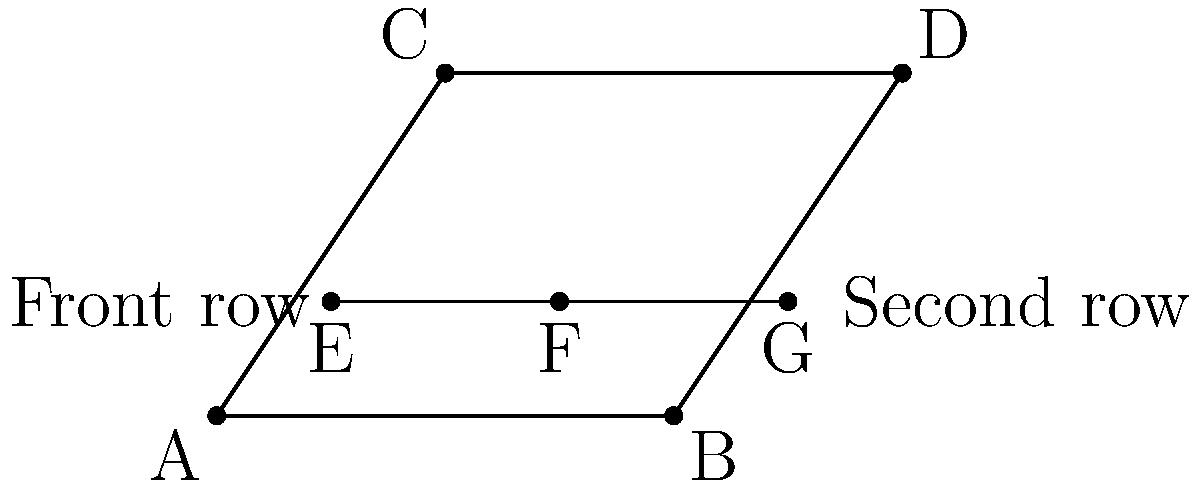In our Kelso rugby team scrum formation, we have two rows of players as shown in the diagram. The front row (triangle ABC) and the second row (triangle EFG) are formed. If AB = 4 units, EF = 2 units, and the ratio of the areas of triangles ABC and EFG is 9:1, prove that these triangles are congruent by similarity. Let's approach this step-by-step:

1) First, we need to understand what it means for triangles to be congruent by similarity. This occurs when one triangle is an enlarged or reduced version of the other, with all angles remaining the same.

2) We're given that the ratio of areas is 9:1. Let's use this information:
   Area of ABC : Area of EFG = 9 : 1

3) We know that for similar triangles, the ratio of their areas is equal to the square of the ratio of their corresponding sides. Let's call this ratio k. So:
   $k^2 = 9:1 = 9$
   $k = 3$

4) This means that each side of triangle ABC is 3 times the corresponding side of triangle EFG.

5) We're given that AB = 4 units and EF = 2 units. Let's check if this fits our ratio:
   $\frac{AB}{EF} = \frac{4}{2} = 2$

6) However, our ratio k should be 3, not 2. This means that EF is not a side corresponding to AB.

7) The corresponding side to AB in triangle EFG must be the base of the triangle, which is not EF, but the entire second row line segment in our scrum formation.

8) This base of triangle EFG must be $\frac{4}{3} = 1.33$ units long for the triangles to be similar with a scale factor of 3.

9) Given that EF = 2 units, the total length of the second row (the base of triangle EFG) must indeed be 2 + 1.33 = 3.33 units, which is $\frac{4}{3}$ of AB.

10) This confirms that the triangles are indeed similar with a scale factor of 3, which matches the given area ratio of 9:1.

Therefore, the front row triangle ABC and the triangle formed by the second row players are congruent by similarity.
Answer: Triangles are similar with scale factor 3 